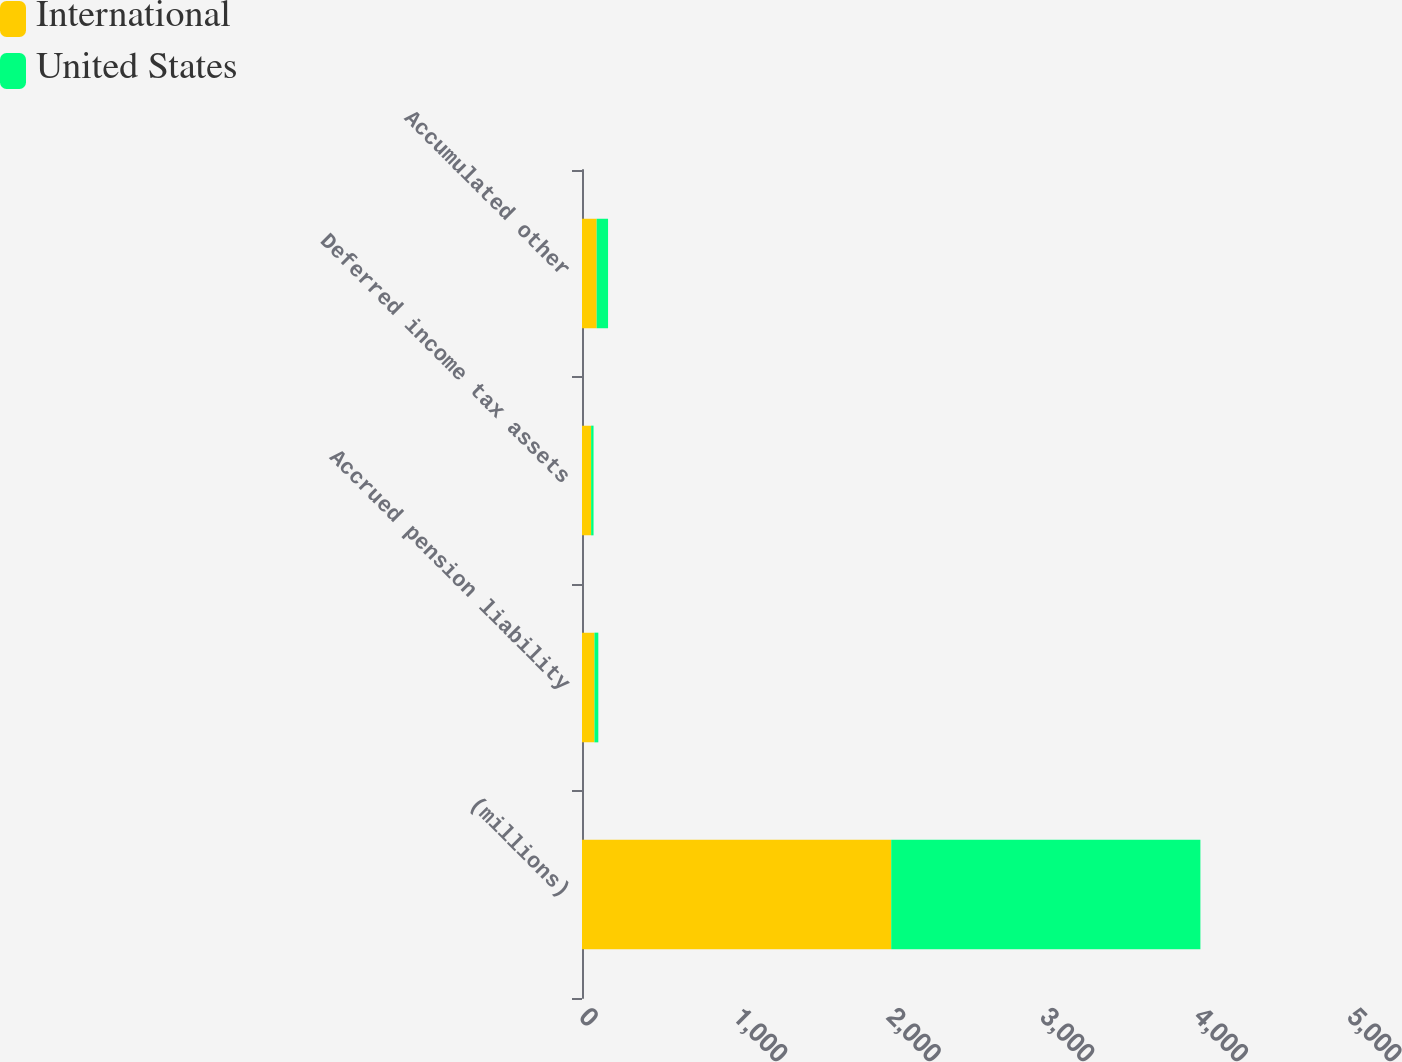Convert chart. <chart><loc_0><loc_0><loc_500><loc_500><stacked_bar_chart><ecel><fcel>(millions)<fcel>Accrued pension liability<fcel>Deferred income tax assets<fcel>Accumulated other<nl><fcel>International<fcel>2013<fcel>81.2<fcel>59.4<fcel>95.5<nl><fcel>United States<fcel>2013<fcel>25<fcel>15.7<fcel>74.1<nl></chart> 